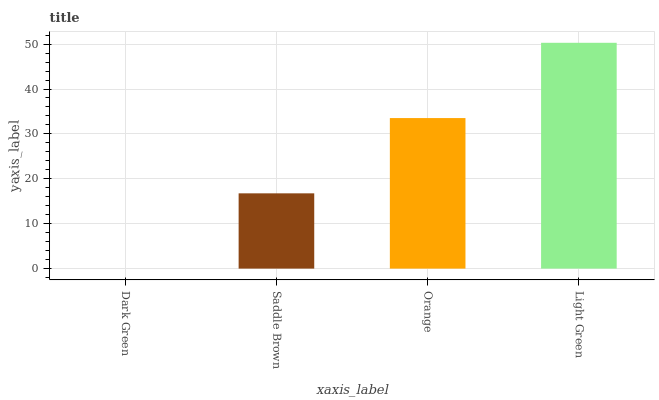Is Dark Green the minimum?
Answer yes or no. Yes. Is Light Green the maximum?
Answer yes or no. Yes. Is Saddle Brown the minimum?
Answer yes or no. No. Is Saddle Brown the maximum?
Answer yes or no. No. Is Saddle Brown greater than Dark Green?
Answer yes or no. Yes. Is Dark Green less than Saddle Brown?
Answer yes or no. Yes. Is Dark Green greater than Saddle Brown?
Answer yes or no. No. Is Saddle Brown less than Dark Green?
Answer yes or no. No. Is Orange the high median?
Answer yes or no. Yes. Is Saddle Brown the low median?
Answer yes or no. Yes. Is Light Green the high median?
Answer yes or no. No. Is Orange the low median?
Answer yes or no. No. 